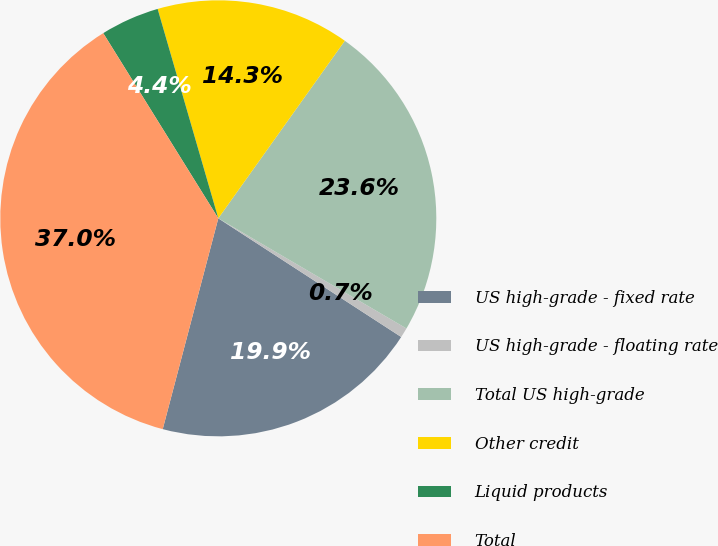<chart> <loc_0><loc_0><loc_500><loc_500><pie_chart><fcel>US high-grade - fixed rate<fcel>US high-grade - floating rate<fcel>Total US high-grade<fcel>Other credit<fcel>Liquid products<fcel>Total<nl><fcel>19.94%<fcel>0.73%<fcel>23.57%<fcel>14.34%<fcel>4.36%<fcel>37.04%<nl></chart> 